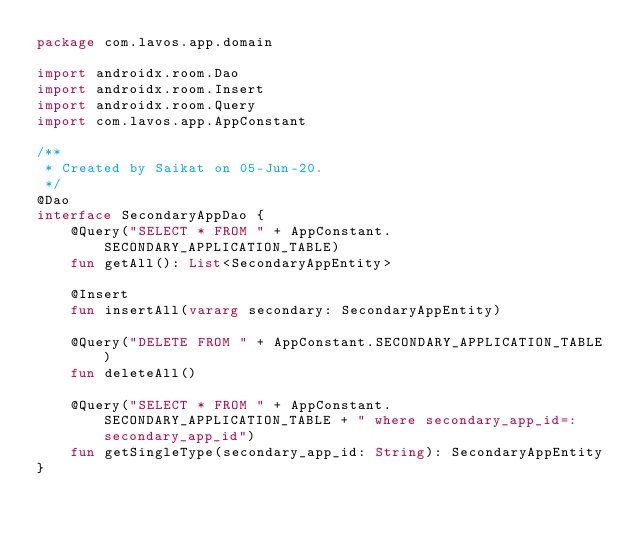<code> <loc_0><loc_0><loc_500><loc_500><_Kotlin_>package com.lavos.app.domain

import androidx.room.Dao
import androidx.room.Insert
import androidx.room.Query
import com.lavos.app.AppConstant

/**
 * Created by Saikat on 05-Jun-20.
 */
@Dao
interface SecondaryAppDao {
    @Query("SELECT * FROM " + AppConstant.SECONDARY_APPLICATION_TABLE)
    fun getAll(): List<SecondaryAppEntity>

    @Insert
    fun insertAll(vararg secondary: SecondaryAppEntity)

    @Query("DELETE FROM " + AppConstant.SECONDARY_APPLICATION_TABLE)
    fun deleteAll()

    @Query("SELECT * FROM " + AppConstant.SECONDARY_APPLICATION_TABLE + " where secondary_app_id=:secondary_app_id")
    fun getSingleType(secondary_app_id: String): SecondaryAppEntity
}</code> 